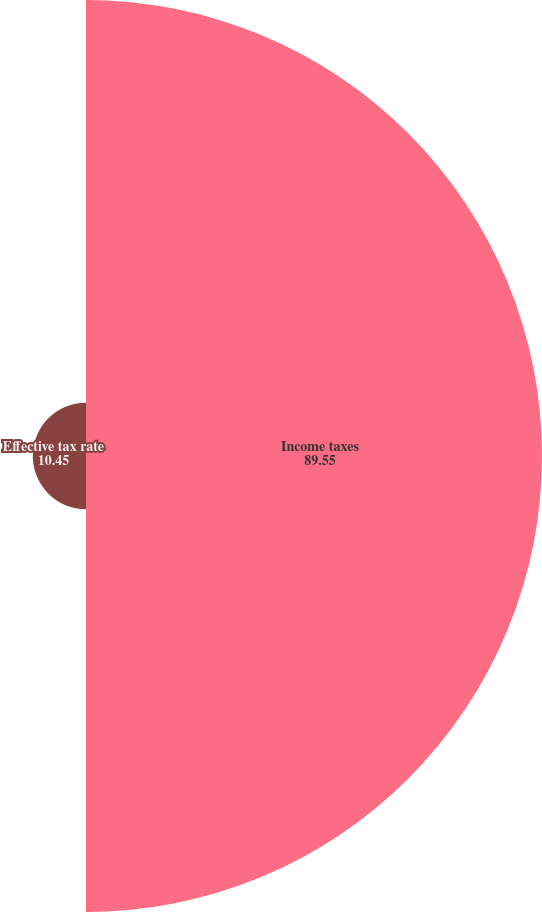Convert chart. <chart><loc_0><loc_0><loc_500><loc_500><pie_chart><fcel>Income taxes<fcel>Effective tax rate<nl><fcel>89.55%<fcel>10.45%<nl></chart> 